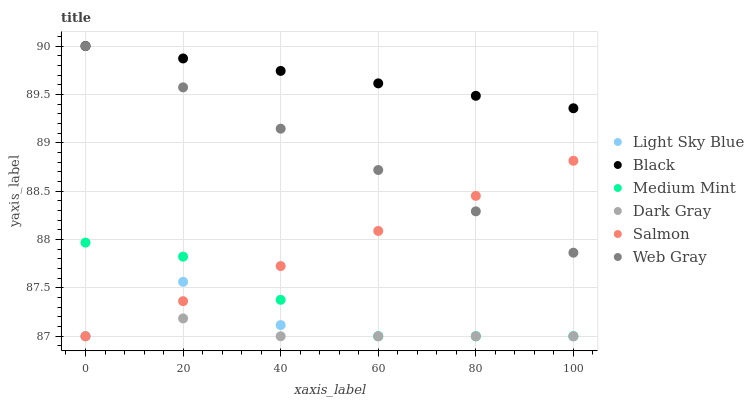Does Dark Gray have the minimum area under the curve?
Answer yes or no. Yes. Does Black have the maximum area under the curve?
Answer yes or no. Yes. Does Web Gray have the minimum area under the curve?
Answer yes or no. No. Does Web Gray have the maximum area under the curve?
Answer yes or no. No. Is Salmon the smoothest?
Answer yes or no. Yes. Is Light Sky Blue the roughest?
Answer yes or no. Yes. Is Web Gray the smoothest?
Answer yes or no. No. Is Web Gray the roughest?
Answer yes or no. No. Does Medium Mint have the lowest value?
Answer yes or no. Yes. Does Web Gray have the lowest value?
Answer yes or no. No. Does Black have the highest value?
Answer yes or no. Yes. Does Salmon have the highest value?
Answer yes or no. No. Is Salmon less than Black?
Answer yes or no. Yes. Is Black greater than Dark Gray?
Answer yes or no. Yes. Does Web Gray intersect Salmon?
Answer yes or no. Yes. Is Web Gray less than Salmon?
Answer yes or no. No. Is Web Gray greater than Salmon?
Answer yes or no. No. Does Salmon intersect Black?
Answer yes or no. No. 